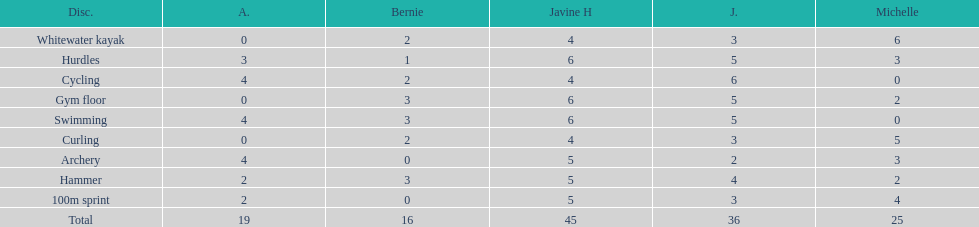Could you parse the entire table? {'header': ['Disc.', 'A.', 'Bernie', 'Javine H', 'J.', 'Michelle'], 'rows': [['Whitewater kayak', '0', '2', '4', '3', '6'], ['Hurdles', '3', '1', '6', '5', '3'], ['Cycling', '4', '2', '4', '6', '0'], ['Gym floor', '0', '3', '6', '5', '2'], ['Swimming', '4', '3', '6', '5', '0'], ['Curling', '0', '2', '4', '3', '5'], ['Archery', '4', '0', '5', '2', '3'], ['Hammer', '2', '3', '5', '4', '2'], ['100m sprint', '2', '0', '5', '3', '4'], ['Total', '19', '16', '45', '36', '25']]} Who reached their best result in cycling? Julia. 